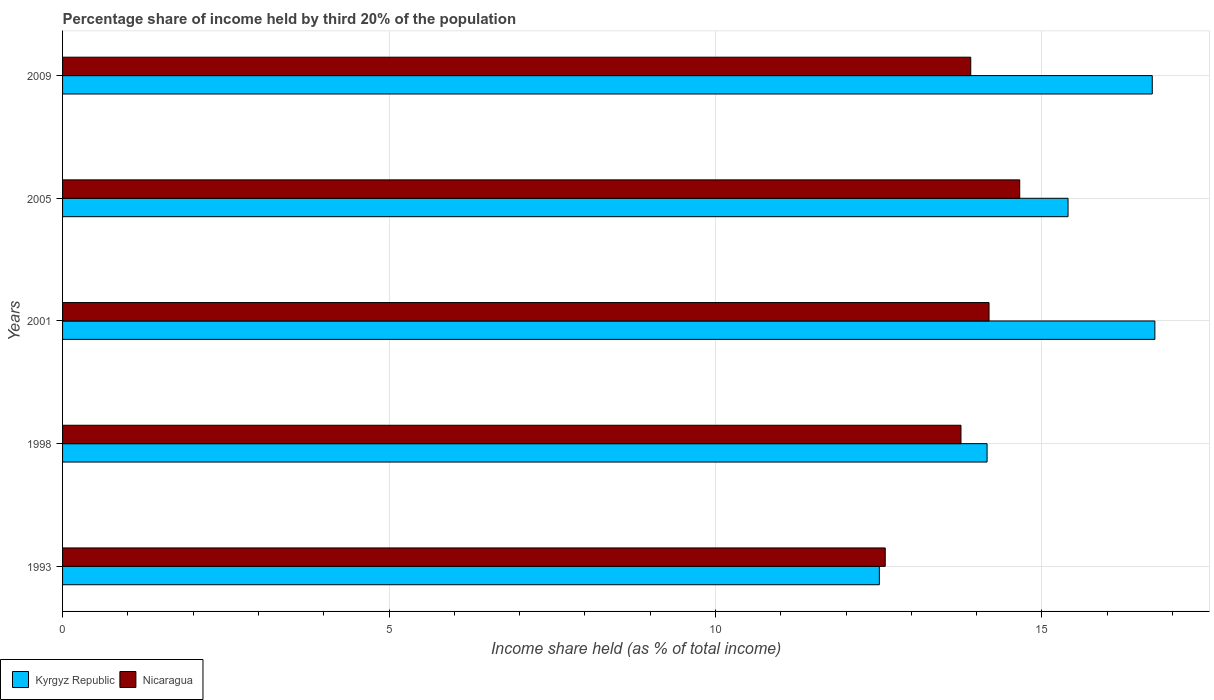How many different coloured bars are there?
Offer a terse response. 2. How many groups of bars are there?
Provide a succinct answer. 5. What is the label of the 5th group of bars from the top?
Give a very brief answer. 1993. In how many cases, is the number of bars for a given year not equal to the number of legend labels?
Ensure brevity in your answer.  0. Across all years, what is the maximum share of income held by third 20% of the population in Nicaragua?
Ensure brevity in your answer.  14.66. Across all years, what is the minimum share of income held by third 20% of the population in Kyrgyz Republic?
Your response must be concise. 12.51. What is the total share of income held by third 20% of the population in Nicaragua in the graph?
Your answer should be compact. 69.12. What is the difference between the share of income held by third 20% of the population in Kyrgyz Republic in 1998 and that in 2009?
Give a very brief answer. -2.53. What is the difference between the share of income held by third 20% of the population in Kyrgyz Republic in 2009 and the share of income held by third 20% of the population in Nicaragua in 1998?
Your answer should be compact. 2.93. What is the average share of income held by third 20% of the population in Nicaragua per year?
Provide a short and direct response. 13.82. In the year 2009, what is the difference between the share of income held by third 20% of the population in Kyrgyz Republic and share of income held by third 20% of the population in Nicaragua?
Your answer should be very brief. 2.78. What is the ratio of the share of income held by third 20% of the population in Kyrgyz Republic in 2001 to that in 2005?
Offer a terse response. 1.09. Is the difference between the share of income held by third 20% of the population in Kyrgyz Republic in 1998 and 2009 greater than the difference between the share of income held by third 20% of the population in Nicaragua in 1998 and 2009?
Make the answer very short. No. What is the difference between the highest and the second highest share of income held by third 20% of the population in Kyrgyz Republic?
Provide a succinct answer. 0.04. What is the difference between the highest and the lowest share of income held by third 20% of the population in Nicaragua?
Your answer should be very brief. 2.06. In how many years, is the share of income held by third 20% of the population in Kyrgyz Republic greater than the average share of income held by third 20% of the population in Kyrgyz Republic taken over all years?
Keep it short and to the point. 3. Is the sum of the share of income held by third 20% of the population in Nicaragua in 1993 and 2001 greater than the maximum share of income held by third 20% of the population in Kyrgyz Republic across all years?
Ensure brevity in your answer.  Yes. What does the 1st bar from the top in 2009 represents?
Your answer should be compact. Nicaragua. What does the 2nd bar from the bottom in 2001 represents?
Make the answer very short. Nicaragua. How many bars are there?
Your answer should be compact. 10. Are all the bars in the graph horizontal?
Your response must be concise. Yes. Are the values on the major ticks of X-axis written in scientific E-notation?
Offer a terse response. No. Does the graph contain any zero values?
Provide a short and direct response. No. Does the graph contain grids?
Provide a succinct answer. Yes. How many legend labels are there?
Offer a very short reply. 2. How are the legend labels stacked?
Provide a succinct answer. Horizontal. What is the title of the graph?
Your answer should be compact. Percentage share of income held by third 20% of the population. Does "Vanuatu" appear as one of the legend labels in the graph?
Keep it short and to the point. No. What is the label or title of the X-axis?
Offer a very short reply. Income share held (as % of total income). What is the label or title of the Y-axis?
Your answer should be very brief. Years. What is the Income share held (as % of total income) in Kyrgyz Republic in 1993?
Give a very brief answer. 12.51. What is the Income share held (as % of total income) of Nicaragua in 1993?
Your answer should be compact. 12.6. What is the Income share held (as % of total income) in Kyrgyz Republic in 1998?
Ensure brevity in your answer.  14.16. What is the Income share held (as % of total income) of Nicaragua in 1998?
Give a very brief answer. 13.76. What is the Income share held (as % of total income) in Kyrgyz Republic in 2001?
Keep it short and to the point. 16.73. What is the Income share held (as % of total income) of Nicaragua in 2001?
Provide a succinct answer. 14.19. What is the Income share held (as % of total income) of Kyrgyz Republic in 2005?
Offer a very short reply. 15.4. What is the Income share held (as % of total income) of Nicaragua in 2005?
Keep it short and to the point. 14.66. What is the Income share held (as % of total income) in Kyrgyz Republic in 2009?
Your response must be concise. 16.69. What is the Income share held (as % of total income) in Nicaragua in 2009?
Your answer should be very brief. 13.91. Across all years, what is the maximum Income share held (as % of total income) of Kyrgyz Republic?
Keep it short and to the point. 16.73. Across all years, what is the maximum Income share held (as % of total income) in Nicaragua?
Provide a succinct answer. 14.66. Across all years, what is the minimum Income share held (as % of total income) in Kyrgyz Republic?
Provide a succinct answer. 12.51. What is the total Income share held (as % of total income) of Kyrgyz Republic in the graph?
Provide a succinct answer. 75.49. What is the total Income share held (as % of total income) in Nicaragua in the graph?
Provide a short and direct response. 69.12. What is the difference between the Income share held (as % of total income) of Kyrgyz Republic in 1993 and that in 1998?
Offer a very short reply. -1.65. What is the difference between the Income share held (as % of total income) in Nicaragua in 1993 and that in 1998?
Your response must be concise. -1.16. What is the difference between the Income share held (as % of total income) in Kyrgyz Republic in 1993 and that in 2001?
Ensure brevity in your answer.  -4.22. What is the difference between the Income share held (as % of total income) of Nicaragua in 1993 and that in 2001?
Offer a very short reply. -1.59. What is the difference between the Income share held (as % of total income) in Kyrgyz Republic in 1993 and that in 2005?
Offer a terse response. -2.89. What is the difference between the Income share held (as % of total income) of Nicaragua in 1993 and that in 2005?
Make the answer very short. -2.06. What is the difference between the Income share held (as % of total income) in Kyrgyz Republic in 1993 and that in 2009?
Give a very brief answer. -4.18. What is the difference between the Income share held (as % of total income) of Nicaragua in 1993 and that in 2009?
Provide a short and direct response. -1.31. What is the difference between the Income share held (as % of total income) in Kyrgyz Republic in 1998 and that in 2001?
Your answer should be very brief. -2.57. What is the difference between the Income share held (as % of total income) in Nicaragua in 1998 and that in 2001?
Provide a succinct answer. -0.43. What is the difference between the Income share held (as % of total income) in Kyrgyz Republic in 1998 and that in 2005?
Provide a succinct answer. -1.24. What is the difference between the Income share held (as % of total income) of Kyrgyz Republic in 1998 and that in 2009?
Provide a short and direct response. -2.53. What is the difference between the Income share held (as % of total income) of Kyrgyz Republic in 2001 and that in 2005?
Give a very brief answer. 1.33. What is the difference between the Income share held (as % of total income) of Nicaragua in 2001 and that in 2005?
Give a very brief answer. -0.47. What is the difference between the Income share held (as % of total income) in Kyrgyz Republic in 2001 and that in 2009?
Your answer should be compact. 0.04. What is the difference between the Income share held (as % of total income) of Nicaragua in 2001 and that in 2009?
Give a very brief answer. 0.28. What is the difference between the Income share held (as % of total income) in Kyrgyz Republic in 2005 and that in 2009?
Your answer should be very brief. -1.29. What is the difference between the Income share held (as % of total income) in Kyrgyz Republic in 1993 and the Income share held (as % of total income) in Nicaragua in 1998?
Provide a succinct answer. -1.25. What is the difference between the Income share held (as % of total income) in Kyrgyz Republic in 1993 and the Income share held (as % of total income) in Nicaragua in 2001?
Your answer should be very brief. -1.68. What is the difference between the Income share held (as % of total income) of Kyrgyz Republic in 1993 and the Income share held (as % of total income) of Nicaragua in 2005?
Your answer should be compact. -2.15. What is the difference between the Income share held (as % of total income) in Kyrgyz Republic in 1993 and the Income share held (as % of total income) in Nicaragua in 2009?
Keep it short and to the point. -1.4. What is the difference between the Income share held (as % of total income) of Kyrgyz Republic in 1998 and the Income share held (as % of total income) of Nicaragua in 2001?
Your answer should be very brief. -0.03. What is the difference between the Income share held (as % of total income) of Kyrgyz Republic in 1998 and the Income share held (as % of total income) of Nicaragua in 2005?
Keep it short and to the point. -0.5. What is the difference between the Income share held (as % of total income) of Kyrgyz Republic in 1998 and the Income share held (as % of total income) of Nicaragua in 2009?
Offer a terse response. 0.25. What is the difference between the Income share held (as % of total income) in Kyrgyz Republic in 2001 and the Income share held (as % of total income) in Nicaragua in 2005?
Your answer should be compact. 2.07. What is the difference between the Income share held (as % of total income) in Kyrgyz Republic in 2001 and the Income share held (as % of total income) in Nicaragua in 2009?
Give a very brief answer. 2.82. What is the difference between the Income share held (as % of total income) in Kyrgyz Republic in 2005 and the Income share held (as % of total income) in Nicaragua in 2009?
Provide a short and direct response. 1.49. What is the average Income share held (as % of total income) in Kyrgyz Republic per year?
Keep it short and to the point. 15.1. What is the average Income share held (as % of total income) of Nicaragua per year?
Provide a short and direct response. 13.82. In the year 1993, what is the difference between the Income share held (as % of total income) of Kyrgyz Republic and Income share held (as % of total income) of Nicaragua?
Provide a short and direct response. -0.09. In the year 2001, what is the difference between the Income share held (as % of total income) of Kyrgyz Republic and Income share held (as % of total income) of Nicaragua?
Your answer should be compact. 2.54. In the year 2005, what is the difference between the Income share held (as % of total income) in Kyrgyz Republic and Income share held (as % of total income) in Nicaragua?
Offer a very short reply. 0.74. In the year 2009, what is the difference between the Income share held (as % of total income) in Kyrgyz Republic and Income share held (as % of total income) in Nicaragua?
Ensure brevity in your answer.  2.78. What is the ratio of the Income share held (as % of total income) in Kyrgyz Republic in 1993 to that in 1998?
Your answer should be very brief. 0.88. What is the ratio of the Income share held (as % of total income) of Nicaragua in 1993 to that in 1998?
Ensure brevity in your answer.  0.92. What is the ratio of the Income share held (as % of total income) in Kyrgyz Republic in 1993 to that in 2001?
Keep it short and to the point. 0.75. What is the ratio of the Income share held (as % of total income) in Nicaragua in 1993 to that in 2001?
Make the answer very short. 0.89. What is the ratio of the Income share held (as % of total income) of Kyrgyz Republic in 1993 to that in 2005?
Your answer should be compact. 0.81. What is the ratio of the Income share held (as % of total income) of Nicaragua in 1993 to that in 2005?
Provide a short and direct response. 0.86. What is the ratio of the Income share held (as % of total income) in Kyrgyz Republic in 1993 to that in 2009?
Make the answer very short. 0.75. What is the ratio of the Income share held (as % of total income) in Nicaragua in 1993 to that in 2009?
Your answer should be very brief. 0.91. What is the ratio of the Income share held (as % of total income) in Kyrgyz Republic in 1998 to that in 2001?
Your answer should be very brief. 0.85. What is the ratio of the Income share held (as % of total income) of Nicaragua in 1998 to that in 2001?
Your answer should be compact. 0.97. What is the ratio of the Income share held (as % of total income) of Kyrgyz Republic in 1998 to that in 2005?
Make the answer very short. 0.92. What is the ratio of the Income share held (as % of total income) of Nicaragua in 1998 to that in 2005?
Your response must be concise. 0.94. What is the ratio of the Income share held (as % of total income) in Kyrgyz Republic in 1998 to that in 2009?
Keep it short and to the point. 0.85. What is the ratio of the Income share held (as % of total income) in Nicaragua in 1998 to that in 2009?
Offer a terse response. 0.99. What is the ratio of the Income share held (as % of total income) of Kyrgyz Republic in 2001 to that in 2005?
Your response must be concise. 1.09. What is the ratio of the Income share held (as % of total income) in Nicaragua in 2001 to that in 2005?
Keep it short and to the point. 0.97. What is the ratio of the Income share held (as % of total income) of Kyrgyz Republic in 2001 to that in 2009?
Provide a short and direct response. 1. What is the ratio of the Income share held (as % of total income) of Nicaragua in 2001 to that in 2009?
Give a very brief answer. 1.02. What is the ratio of the Income share held (as % of total income) in Kyrgyz Republic in 2005 to that in 2009?
Offer a terse response. 0.92. What is the ratio of the Income share held (as % of total income) of Nicaragua in 2005 to that in 2009?
Provide a succinct answer. 1.05. What is the difference between the highest and the second highest Income share held (as % of total income) in Kyrgyz Republic?
Provide a succinct answer. 0.04. What is the difference between the highest and the second highest Income share held (as % of total income) of Nicaragua?
Your answer should be very brief. 0.47. What is the difference between the highest and the lowest Income share held (as % of total income) of Kyrgyz Republic?
Your answer should be compact. 4.22. What is the difference between the highest and the lowest Income share held (as % of total income) of Nicaragua?
Your answer should be very brief. 2.06. 